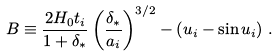Convert formula to latex. <formula><loc_0><loc_0><loc_500><loc_500>B \equiv \frac { 2 H _ { 0 } t _ { i } } { 1 + \delta _ { \ast } } \left ( \frac { \delta _ { \ast } } { a _ { i } } \right ) ^ { 3 / 2 } - \left ( u _ { i } - \sin { u _ { i } } \right ) \, .</formula> 